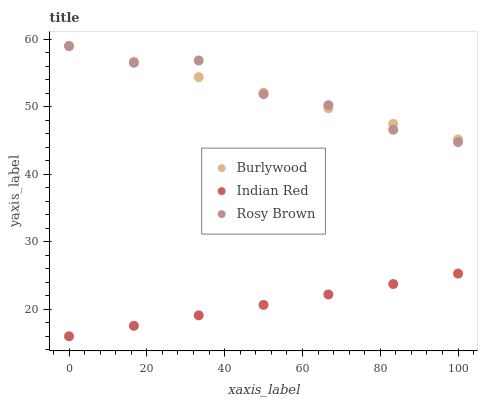Does Indian Red have the minimum area under the curve?
Answer yes or no. Yes. Does Rosy Brown have the maximum area under the curve?
Answer yes or no. Yes. Does Rosy Brown have the minimum area under the curve?
Answer yes or no. No. Does Indian Red have the maximum area under the curve?
Answer yes or no. No. Is Indian Red the smoothest?
Answer yes or no. Yes. Is Rosy Brown the roughest?
Answer yes or no. Yes. Is Rosy Brown the smoothest?
Answer yes or no. No. Is Indian Red the roughest?
Answer yes or no. No. Does Indian Red have the lowest value?
Answer yes or no. Yes. Does Rosy Brown have the lowest value?
Answer yes or no. No. Does Rosy Brown have the highest value?
Answer yes or no. Yes. Does Indian Red have the highest value?
Answer yes or no. No. Is Indian Red less than Burlywood?
Answer yes or no. Yes. Is Rosy Brown greater than Indian Red?
Answer yes or no. Yes. Does Burlywood intersect Rosy Brown?
Answer yes or no. Yes. Is Burlywood less than Rosy Brown?
Answer yes or no. No. Is Burlywood greater than Rosy Brown?
Answer yes or no. No. Does Indian Red intersect Burlywood?
Answer yes or no. No. 